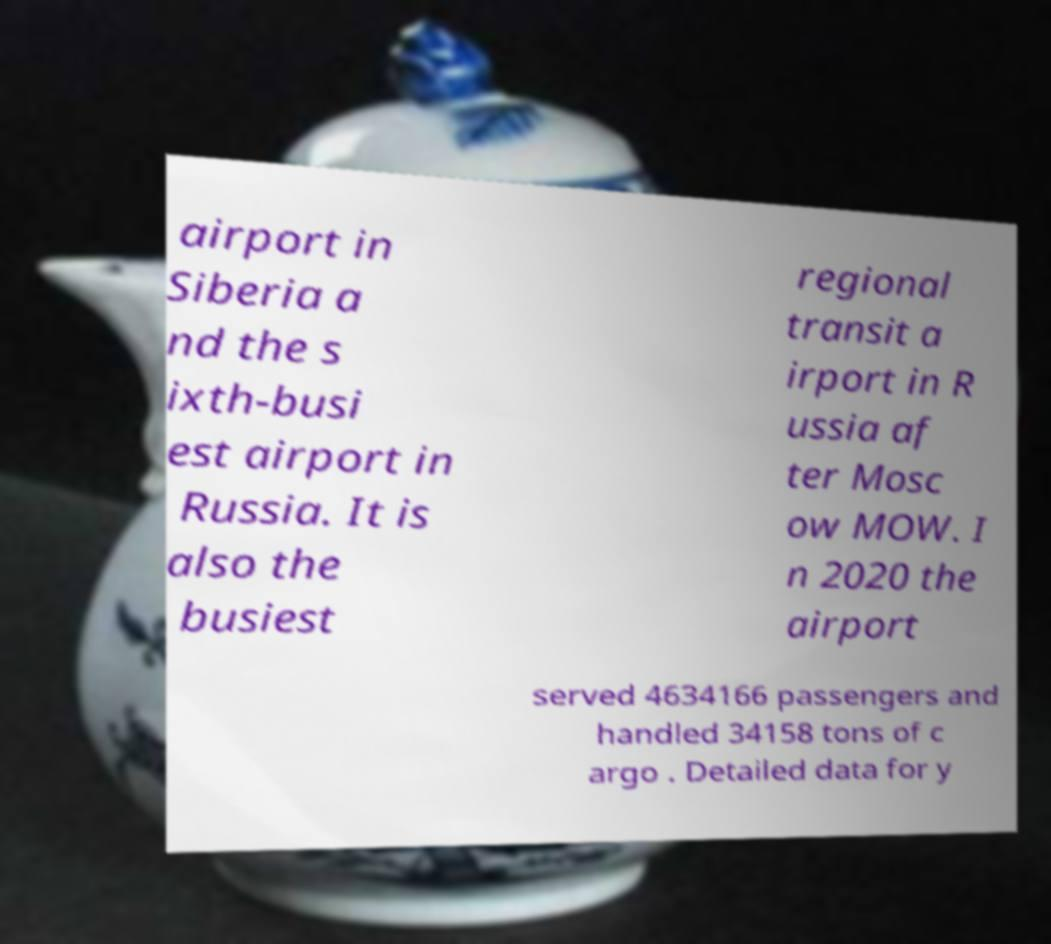I need the written content from this picture converted into text. Can you do that? airport in Siberia a nd the s ixth-busi est airport in Russia. It is also the busiest regional transit a irport in R ussia af ter Mosc ow MOW. I n 2020 the airport served 4634166 passengers and handled 34158 tons of c argo . Detailed data for y 